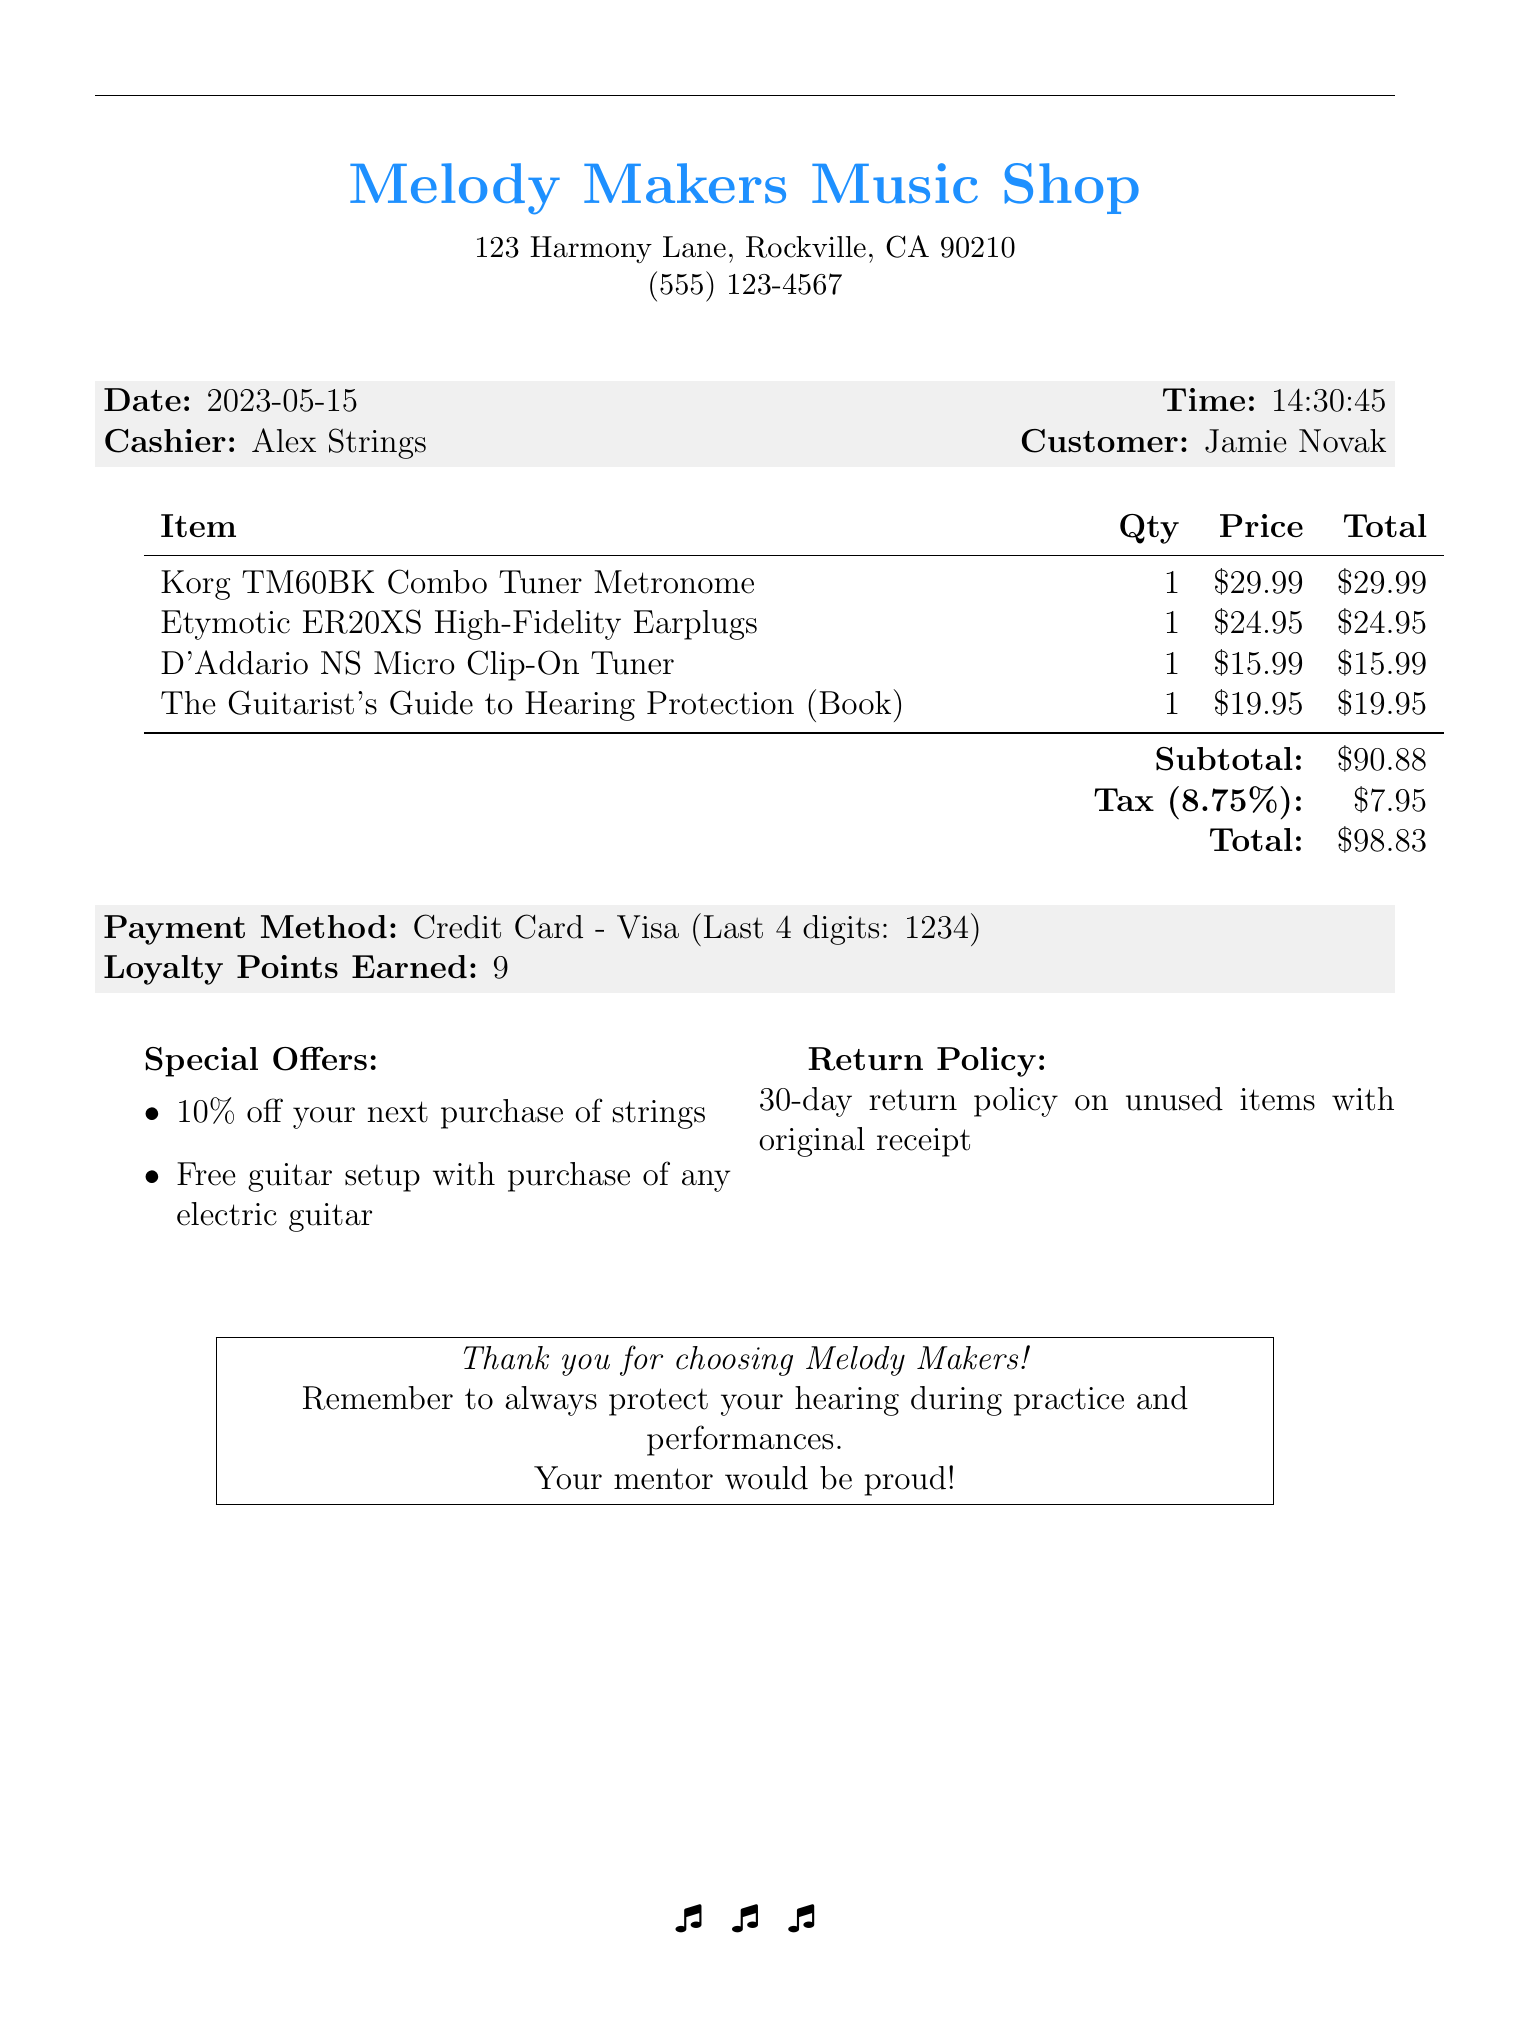What is the name of the store? The name of the store is mentioned at the top of the receipt.
Answer: Melody Makers Music Shop Who was the cashier? The cashier's name is provided in the receipt's details.
Answer: Alex Strings What item was purchased for the least amount? Comparing the prices of items listed shows which was the lowest.
Answer: D'Addario NS Micro Clip-On Tuner What is the tax amount? The tax amount is calculated based on the subtotal provided in the document.
Answer: $7.95 How many loyalty points were earned? The receipt specifically states the number of loyalty points earned on this purchase.
Answer: 9 What is the date of the transaction? The exact date of the transaction is stated on the receipt.
Answer: 2023-05-15 What is the return policy on the receipt? The return policy details are summarized in the document.
Answer: 30-day return policy on unused items with original receipt What special offer is mentioned regarding strings? The special offers section lists offers available for the customer.
Answer: 10% off your next purchase of strings What is the payment method used for this transaction? The details about the payment method are included in the receipt.
Answer: Credit Card - Visa 